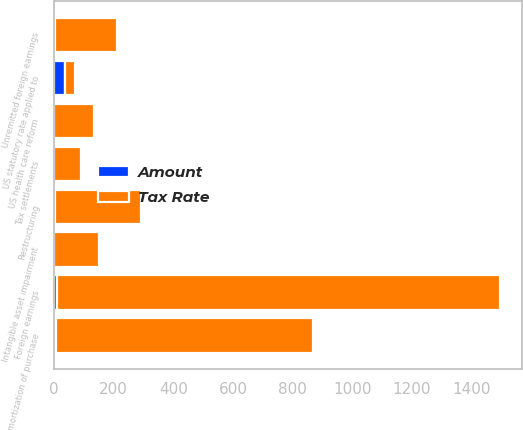<chart> <loc_0><loc_0><loc_500><loc_500><stacked_bar_chart><ecel><fcel>US statutory rate applied to<fcel>Foreign earnings<fcel>Tax settlements<fcel>Unremitted foreign earnings<fcel>Amortization of purchase<fcel>Restructuring<fcel>US health care reform<fcel>Intangible asset impairment<nl><fcel>Tax Rate<fcel>35<fcel>1486<fcel>89<fcel>209<fcel>865<fcel>289<fcel>134<fcel>148<nl><fcel>Amount<fcel>35<fcel>8.6<fcel>0.5<fcel>1.2<fcel>5<fcel>1.7<fcel>0.8<fcel>0.9<nl></chart> 